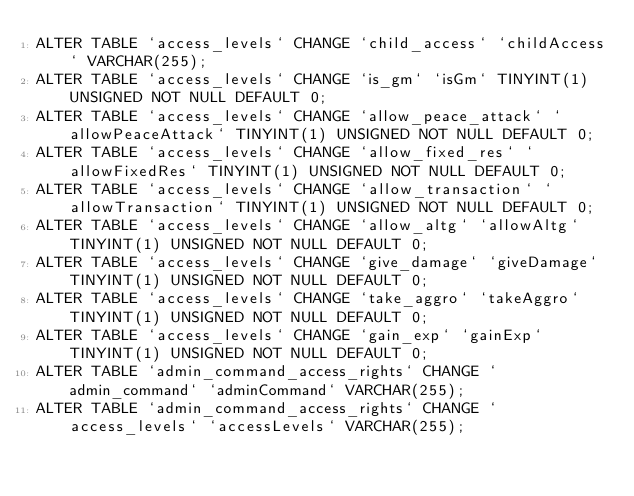Convert code to text. <code><loc_0><loc_0><loc_500><loc_500><_SQL_>ALTER TABLE `access_levels` CHANGE `child_access` `childAccess` VARCHAR(255);
ALTER TABLE `access_levels` CHANGE `is_gm` `isGm` TINYINT(1) UNSIGNED NOT NULL DEFAULT 0;
ALTER TABLE `access_levels` CHANGE `allow_peace_attack` `allowPeaceAttack` TINYINT(1) UNSIGNED NOT NULL DEFAULT 0;
ALTER TABLE `access_levels` CHANGE `allow_fixed_res` `allowFixedRes` TINYINT(1) UNSIGNED NOT NULL DEFAULT 0;
ALTER TABLE `access_levels` CHANGE `allow_transaction` `allowTransaction` TINYINT(1) UNSIGNED NOT NULL DEFAULT 0;
ALTER TABLE `access_levels` CHANGE `allow_altg` `allowAltg` TINYINT(1) UNSIGNED NOT NULL DEFAULT 0;
ALTER TABLE `access_levels` CHANGE `give_damage` `giveDamage` TINYINT(1) UNSIGNED NOT NULL DEFAULT 0;
ALTER TABLE `access_levels` CHANGE `take_aggro` `takeAggro` TINYINT(1) UNSIGNED NOT NULL DEFAULT 0;
ALTER TABLE `access_levels` CHANGE `gain_exp` `gainExp` TINYINT(1) UNSIGNED NOT NULL DEFAULT 0;
ALTER TABLE `admin_command_access_rights` CHANGE `admin_command` `adminCommand` VARCHAR(255);
ALTER TABLE `admin_command_access_rights` CHANGE `access_levels` `accessLevels` VARCHAR(255);</code> 